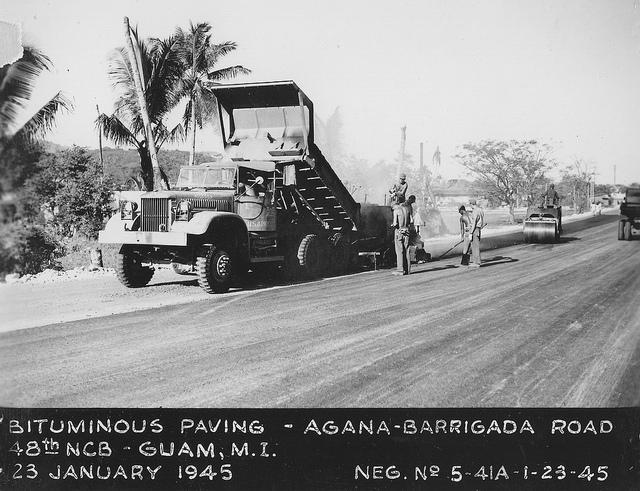In what year what this photo taken?
Quick response, please. 1945. Is this in the USA?
Give a very brief answer. No. Where was this picture taken?
Answer briefly. Guam. Why are the men in the street?
Concise answer only. Working. What is the number in the lower right corner?
Write a very short answer. 5-41a-1-23-45. What date was this picture taken?
Keep it brief. January 23 1945. 